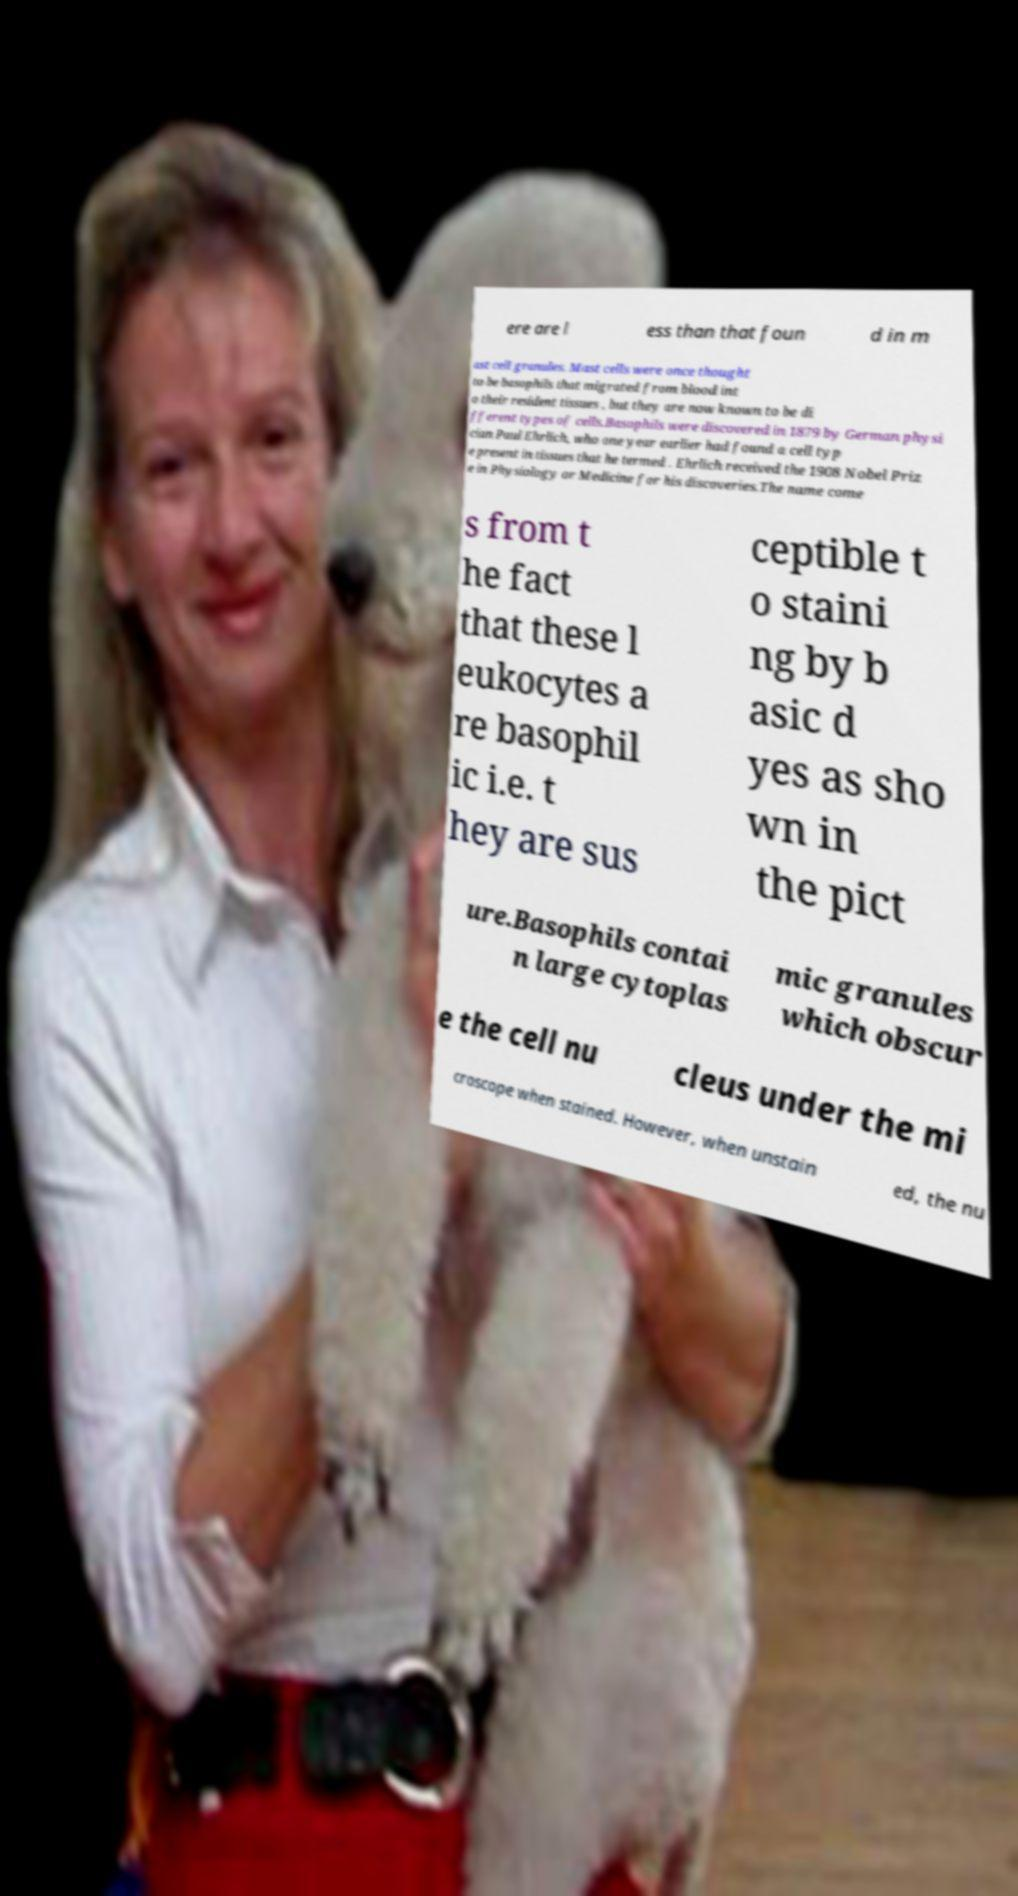Can you read and provide the text displayed in the image?This photo seems to have some interesting text. Can you extract and type it out for me? ere are l ess than that foun d in m ast cell granules. Mast cells were once thought to be basophils that migrated from blood int o their resident tissues , but they are now known to be di fferent types of cells.Basophils were discovered in 1879 by German physi cian Paul Ehrlich, who one year earlier had found a cell typ e present in tissues that he termed . Ehrlich received the 1908 Nobel Priz e in Physiology or Medicine for his discoveries.The name come s from t he fact that these l eukocytes a re basophil ic i.e. t hey are sus ceptible t o staini ng by b asic d yes as sho wn in the pict ure.Basophils contai n large cytoplas mic granules which obscur e the cell nu cleus under the mi croscope when stained. However, when unstain ed, the nu 